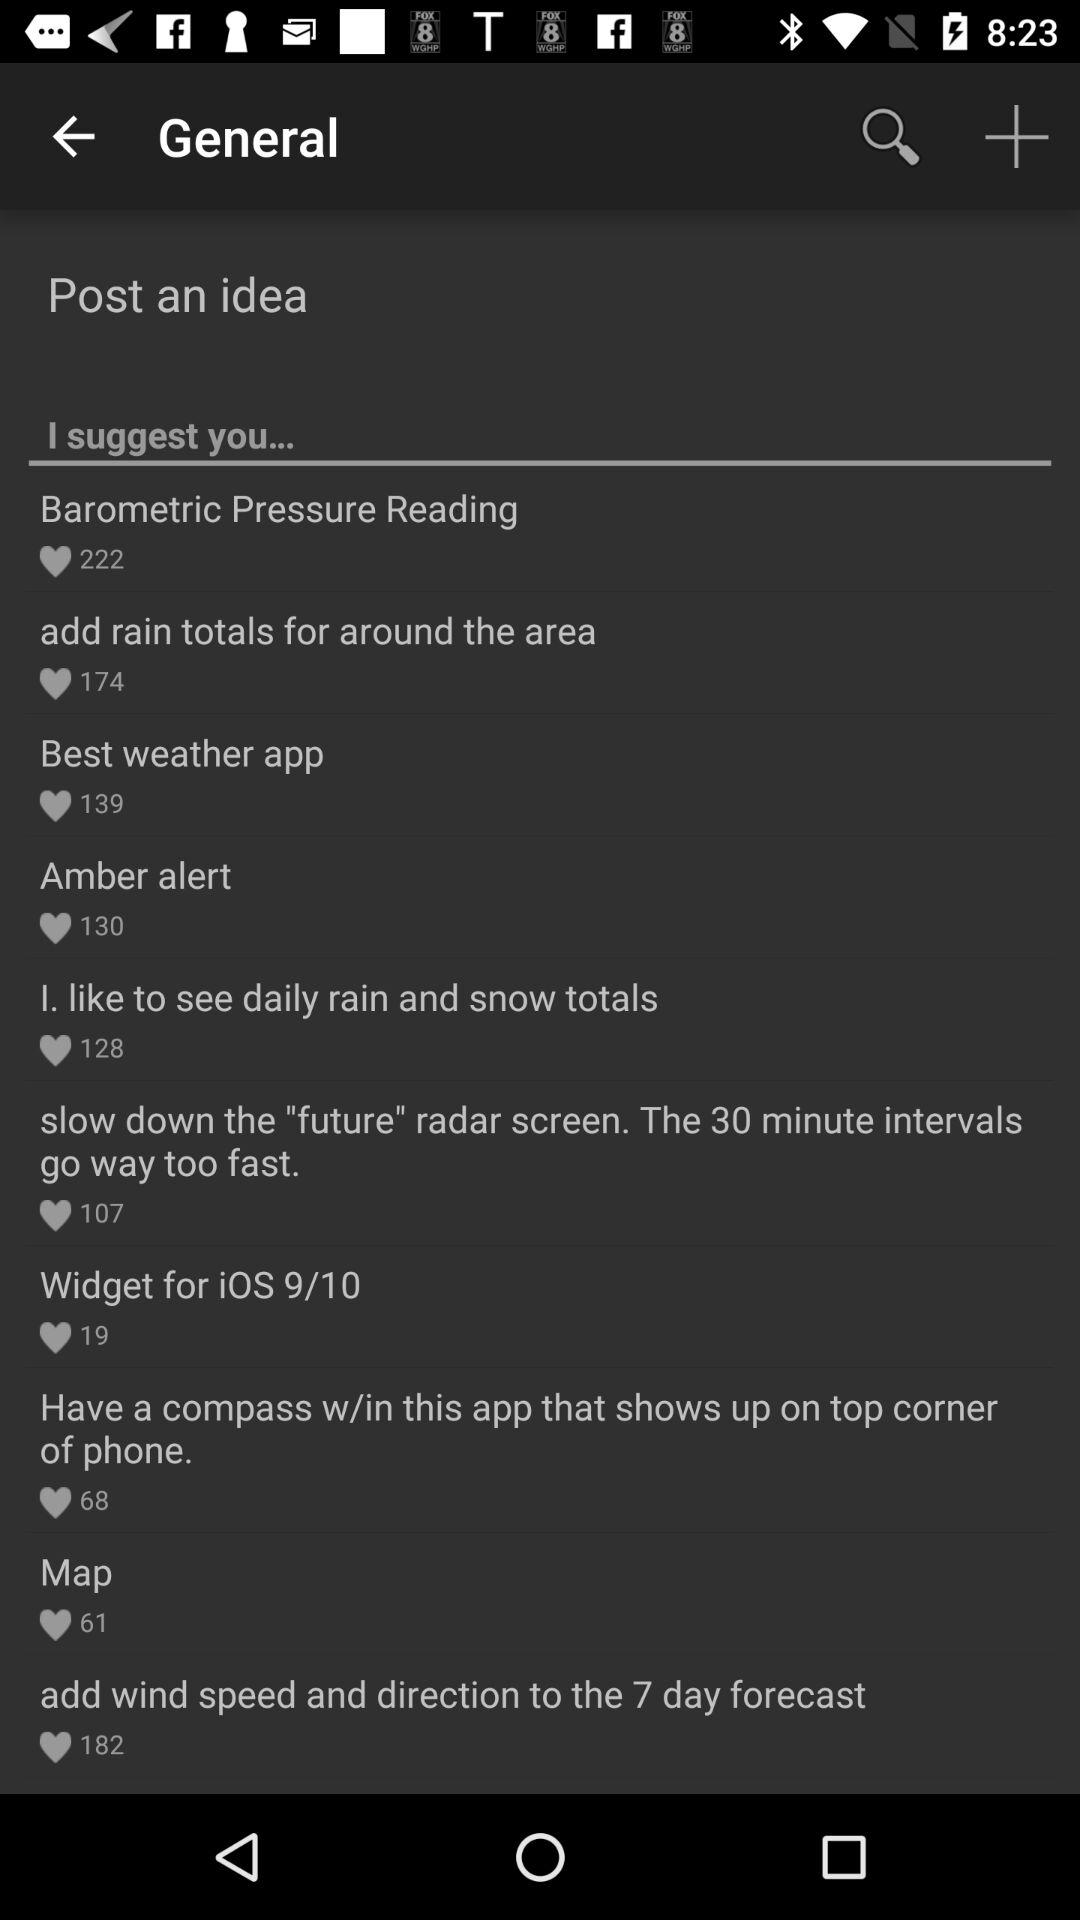What is the number of likes of "Amber alert"? The number of likes of "Amber alert" is 130. 